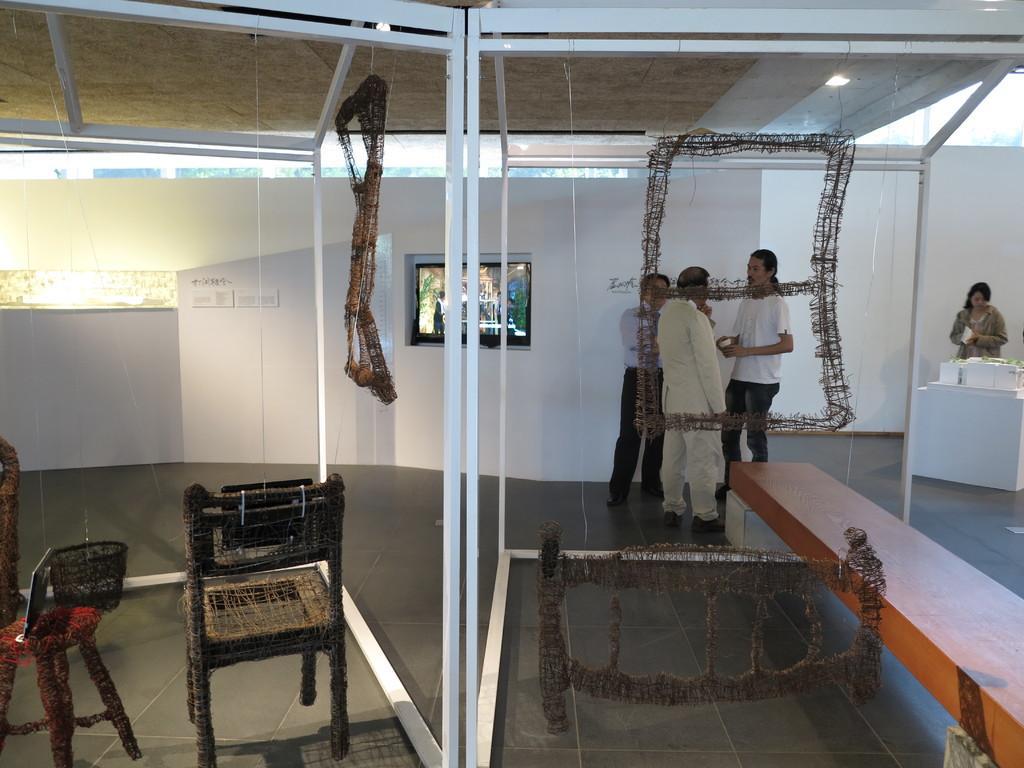How would you summarize this image in a sentence or two? In this picture I can see four persons standing, there is a television, there is a stool, chair and there are some objects. 